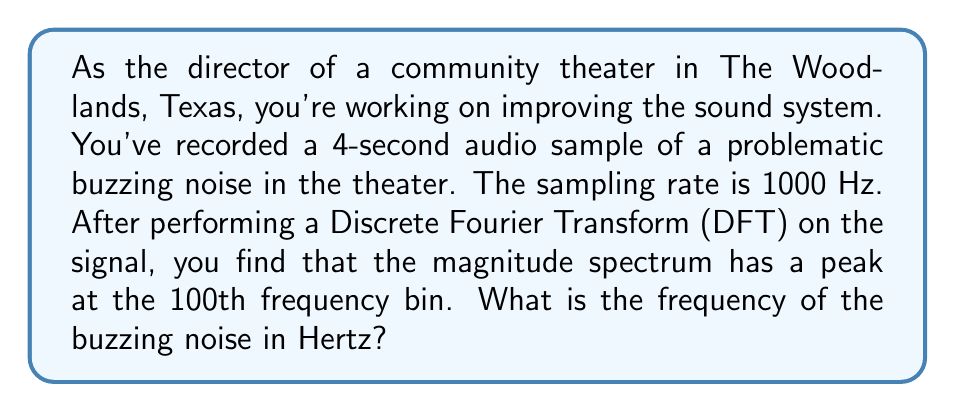Teach me how to tackle this problem. To solve this problem, we need to understand the relationship between the DFT bins and the actual frequencies they represent. Let's break it down step-by-step:

1. First, we need to determine the frequency resolution of the DFT. This is given by:

   $$\Delta f = \frac{f_s}{N}$$

   where $f_s$ is the sampling frequency and $N$ is the total number of samples.

2. We know the sampling rate $f_s = 1000$ Hz and the duration of the sample is 4 seconds. So, the number of samples is:

   $$N = f_s \times \text{duration} = 1000 \times 4 = 4000$$

3. Now we can calculate the frequency resolution:

   $$\Delta f = \frac{1000 \text{ Hz}}{4000} = 0.25 \text{ Hz}$$

4. The frequency corresponding to the kth bin in the DFT is given by:

   $$f_k = k \times \Delta f$$

   where $k$ is the bin number.

5. We're told that the peak is at the 100th bin, so $k = 100$. Therefore, the frequency of the buzzing noise is:

   $$f_{100} = 100 \times 0.25 \text{ Hz} = 25 \text{ Hz}$$

Thus, the buzzing noise has a frequency of 25 Hz.
Answer: 25 Hz 